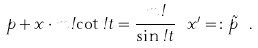Convert formula to latex. <formula><loc_0><loc_0><loc_500><loc_500>p + x \cdot m \omega \cot \omega t = \frac { m \omega } { \sin \omega t } \ x ^ { \prime } = \colon \tilde { p } \ .</formula> 